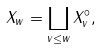<formula> <loc_0><loc_0><loc_500><loc_500>X _ { w } = \coprod _ { v \leq w } X _ { v } ^ { \circ } ,</formula> 